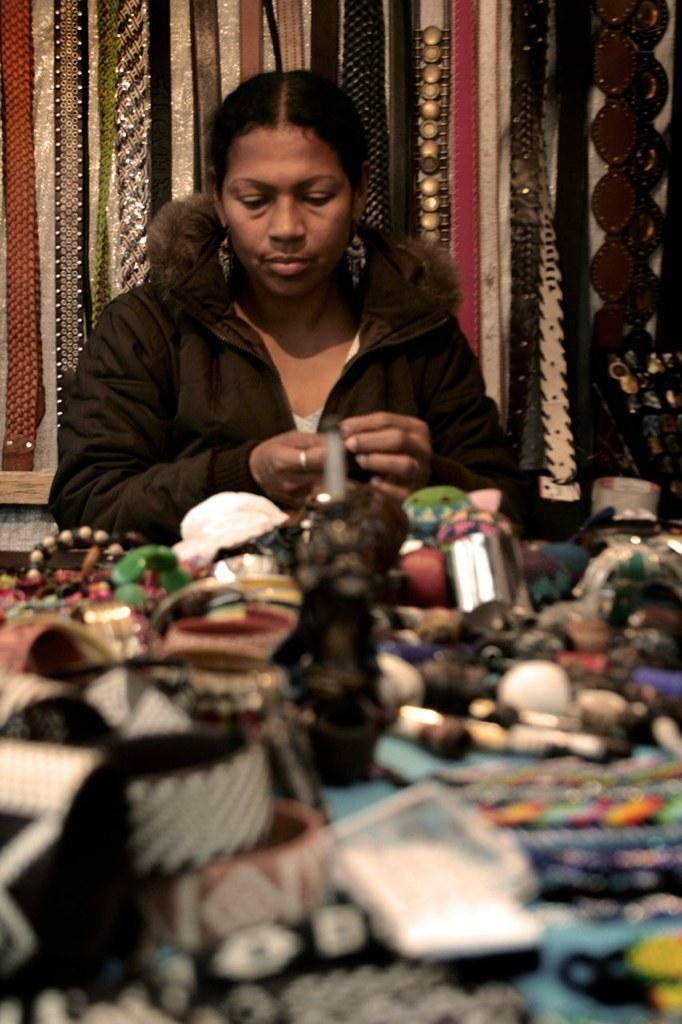What is the lady in the image doing? The lady is sitting on a chair in the image. What can be seen on the table in the image? There are objects on a table in the image. What is hanging from the wall in the image? There are objects hanging from the wall in the image. What color is the paint on the lady's face in the image? There is no paint visible on the lady's face in the image. 